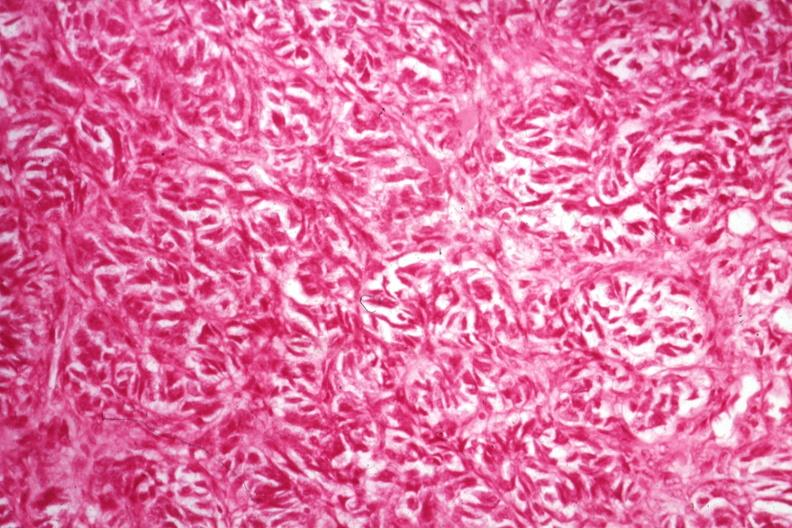what is present?
Answer the question using a single word or phrase. Hilar cell tumor 